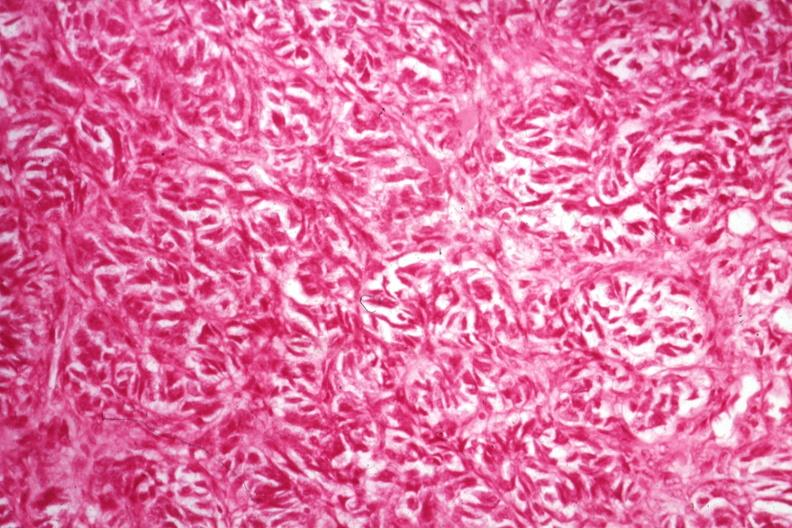what is present?
Answer the question using a single word or phrase. Hilar cell tumor 